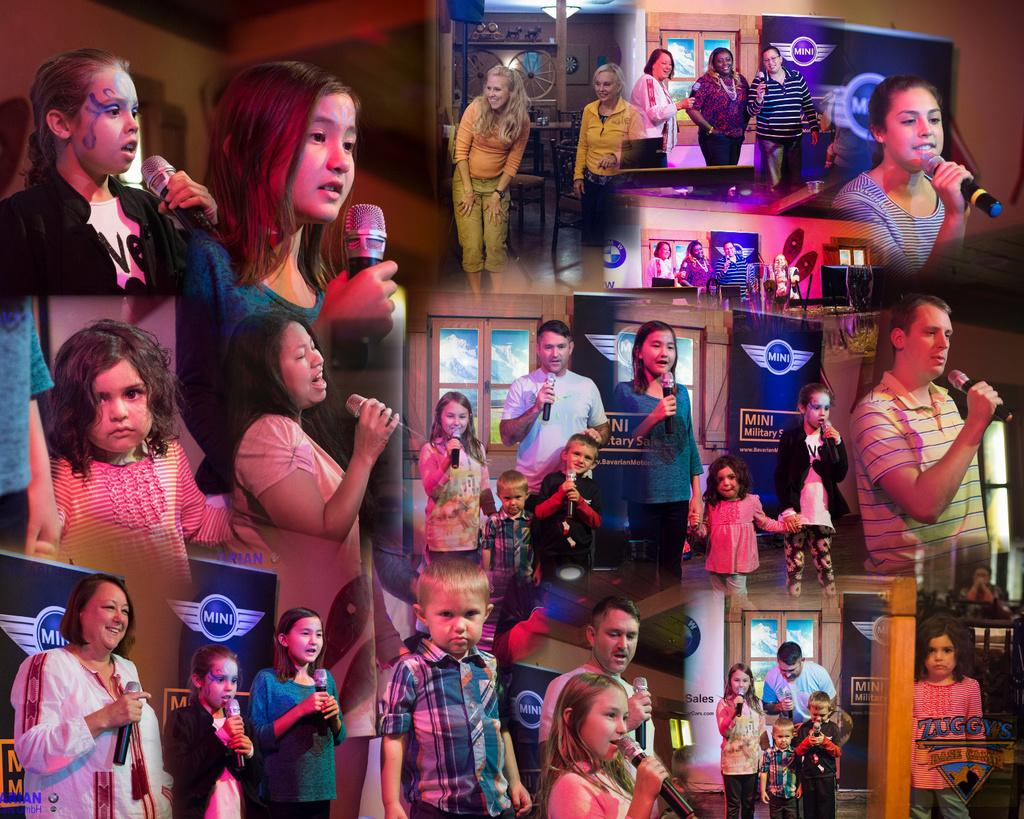How many people can be seen in the image? A: There are many people in the image. What type of image is present in the scene? There is a collage image in the scene. What are some people doing in the image? Some people are holding microphones and speaking into them. What else can be seen in the image? There are advertising boards in the image. Are there any fairies visible in the image? No, there are no fairies present in the image. What type of parent is shown interacting with the people in the image? There is no parent present in the image; it features a gathering of people and other elements. 